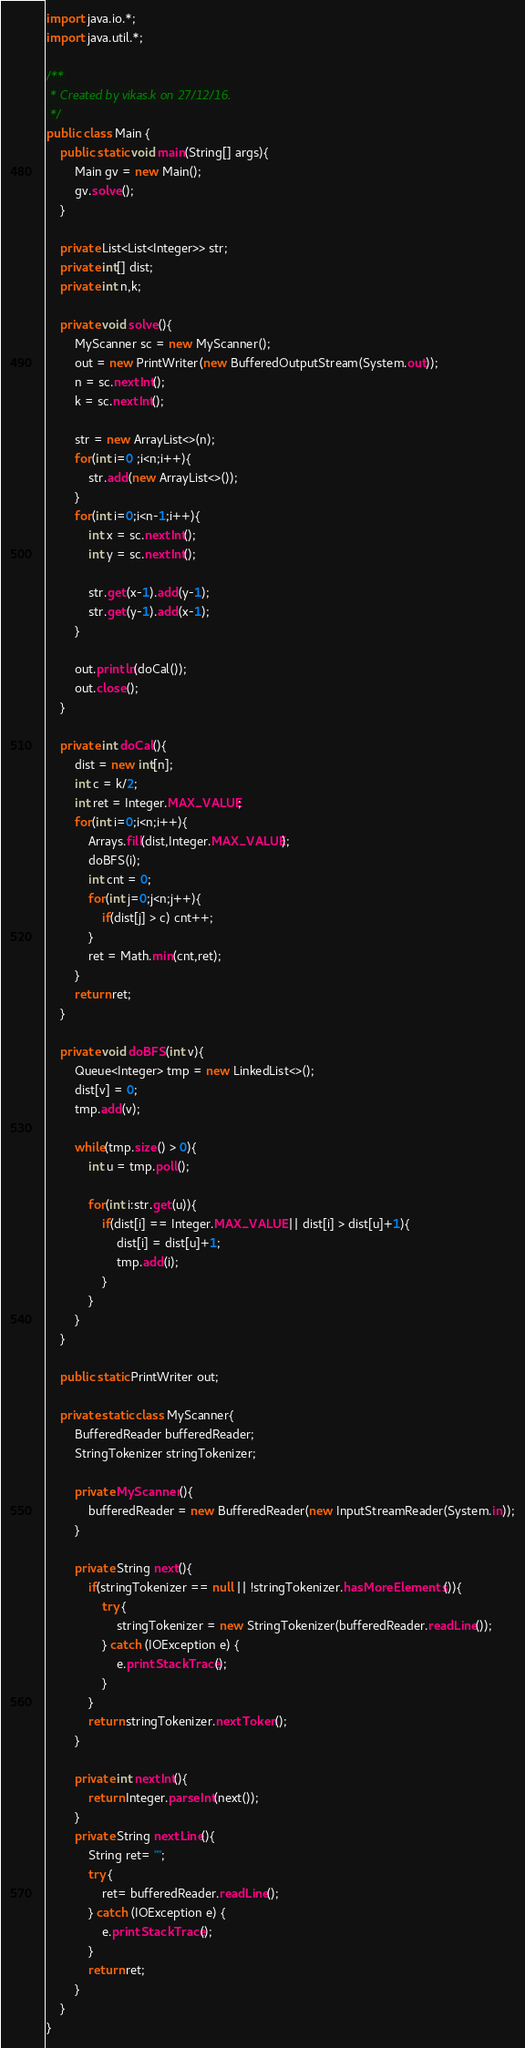<code> <loc_0><loc_0><loc_500><loc_500><_Java_>import java.io.*;
import java.util.*;

/**
 * Created by vikas.k on 27/12/16.
 */
public class Main {
    public static void main(String[] args){
        Main gv = new Main();
        gv.solve();
    }

    private List<List<Integer>> str;
    private int[] dist;
    private int n,k;

    private void solve(){
        MyScanner sc = new MyScanner();
        out = new PrintWriter(new BufferedOutputStream(System.out));
        n = sc.nextInt();
        k = sc.nextInt();

        str = new ArrayList<>(n);
        for(int i=0 ;i<n;i++){
            str.add(new ArrayList<>());
        }
        for(int i=0;i<n-1;i++){
            int x = sc.nextInt();
            int y = sc.nextInt();

            str.get(x-1).add(y-1);
            str.get(y-1).add(x-1);
        }

        out.println(doCal());
        out.close();
    }

    private int doCal(){
        dist = new int[n];
        int c = k/2;
        int ret = Integer.MAX_VALUE;
        for(int i=0;i<n;i++){
            Arrays.fill(dist,Integer.MAX_VALUE);
            doBFS(i);
            int cnt = 0;
            for(int j=0;j<n;j++){
                if(dist[j] > c) cnt++;
            }
            ret = Math.min(cnt,ret);
        }
        return ret;
    }

    private void doBFS(int v){
        Queue<Integer> tmp = new LinkedList<>();
        dist[v] = 0;
        tmp.add(v);

        while(tmp.size() > 0){
            int u = tmp.poll();

            for(int i:str.get(u)){
                if(dist[i] == Integer.MAX_VALUE || dist[i] > dist[u]+1){
                    dist[i] = dist[u]+1;
                    tmp.add(i);
                }
            }
        }
    }

    public static PrintWriter out;

    private static class MyScanner{
        BufferedReader bufferedReader;
        StringTokenizer stringTokenizer;

        private MyScanner(){
            bufferedReader = new BufferedReader(new InputStreamReader(System.in));
        }

        private String next(){
            if(stringTokenizer == null || !stringTokenizer.hasMoreElements()){
                try {
                    stringTokenizer = new StringTokenizer(bufferedReader.readLine());
                } catch (IOException e) {
                    e.printStackTrace();
                }
            }
            return stringTokenizer.nextToken();
        }

        private int nextInt(){
            return Integer.parseInt(next());
        }
        private String nextLine(){
            String ret= "";
            try {
                ret= bufferedReader.readLine();
            } catch (IOException e) {
                e.printStackTrace();
            }
            return ret;
        }
    }
}
</code> 